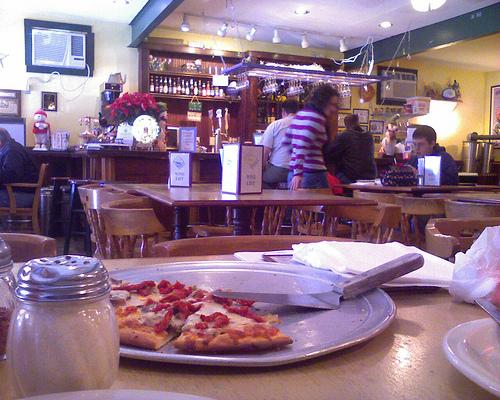What does the tool near the pizza do? Please explain your reasoning. scoop pizza. The tool is flat and triangular, which is the shape it would need to be in order to securely pick up pizza so that's obviously its intended use. 